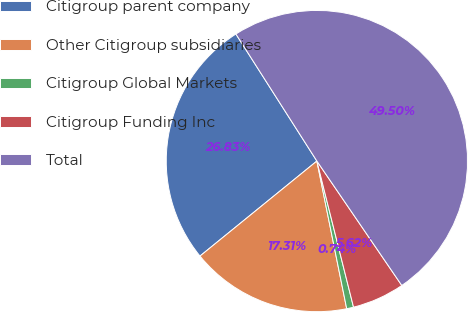Convert chart. <chart><loc_0><loc_0><loc_500><loc_500><pie_chart><fcel>Citigroup parent company<fcel>Other Citigroup subsidiaries<fcel>Citigroup Global Markets<fcel>Citigroup Funding Inc<fcel>Total<nl><fcel>26.83%<fcel>17.31%<fcel>0.74%<fcel>5.62%<fcel>49.5%<nl></chart> 